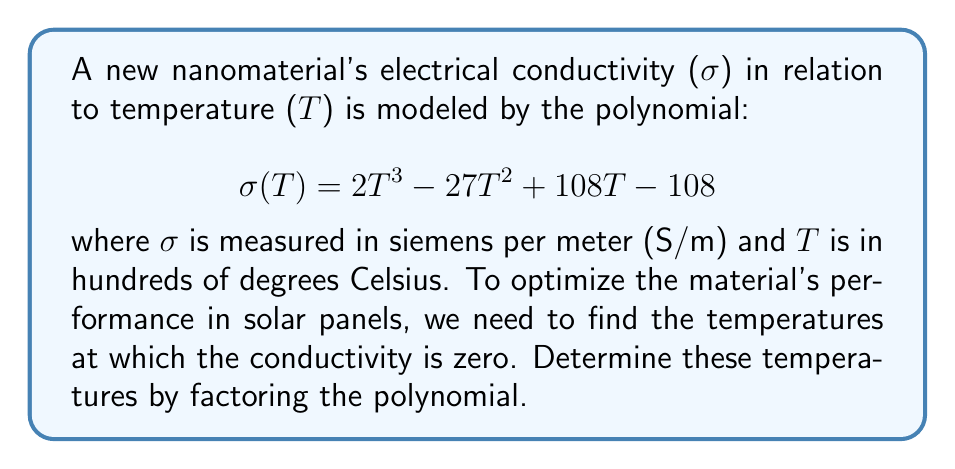Help me with this question. To solve this problem, we need to factor the polynomial $\sigma(T) = 2T^3 - 27T^2 + 108T - 108$ and find its roots. These roots will represent the temperatures at which the conductivity is zero.

Step 1: Factor out the greatest common factor (GCF).
The GCF of all terms is 1, so we can't factor anything out.

Step 2: Check if it's a perfect cube polynomial.
It's not a perfect cube, so we move on to the next step.

Step 3: Try grouping.
$\sigma(T) = 2T^3 - 27T^2 + 108T - 108$
$= (2T^3 - 27T^2) + (108T - 108)$
$= T^2(2T - 27) + 108(T - 1)$

Step 4: Factor out $(T - 1)$ from both groups.
$= T^2(2T - 27) + 108(T - 1)$
$= (T - 1)(2T^2 + 2T - 108)$

Step 5: Factor the quadratic term $(2T^2 + 2T - 108)$.
We can factor this using the quadratic formula or by guessing factors.
$2T^2 + 2T - 108 = 2(T^2 + T - 54) = 2(T + 9)(T - 8)$

Step 6: Write the fully factored polynomial.
$\sigma(T) = (T - 1)(2T^2 + 2T - 108)$
$= (T - 1)(2(T + 9)(T - 8))$
$= 2(T - 1)(T + 9)(T - 8)$

The roots of this polynomial are the values of $T$ that make each factor equal to zero:
$T - 1 = 0$, so $T = 1$
$T + 9 = 0$, so $T = -9$ (not relevant in this context as temperature is in hundreds of °C)
$T - 8 = 0$, so $T = 8$

Therefore, the conductivity is zero at $T = 1$ (100°C) and $T = 8$ (800°C).
Answer: The temperatures at which the nanomaterial's conductivity is zero are 100°C and 800°C. 